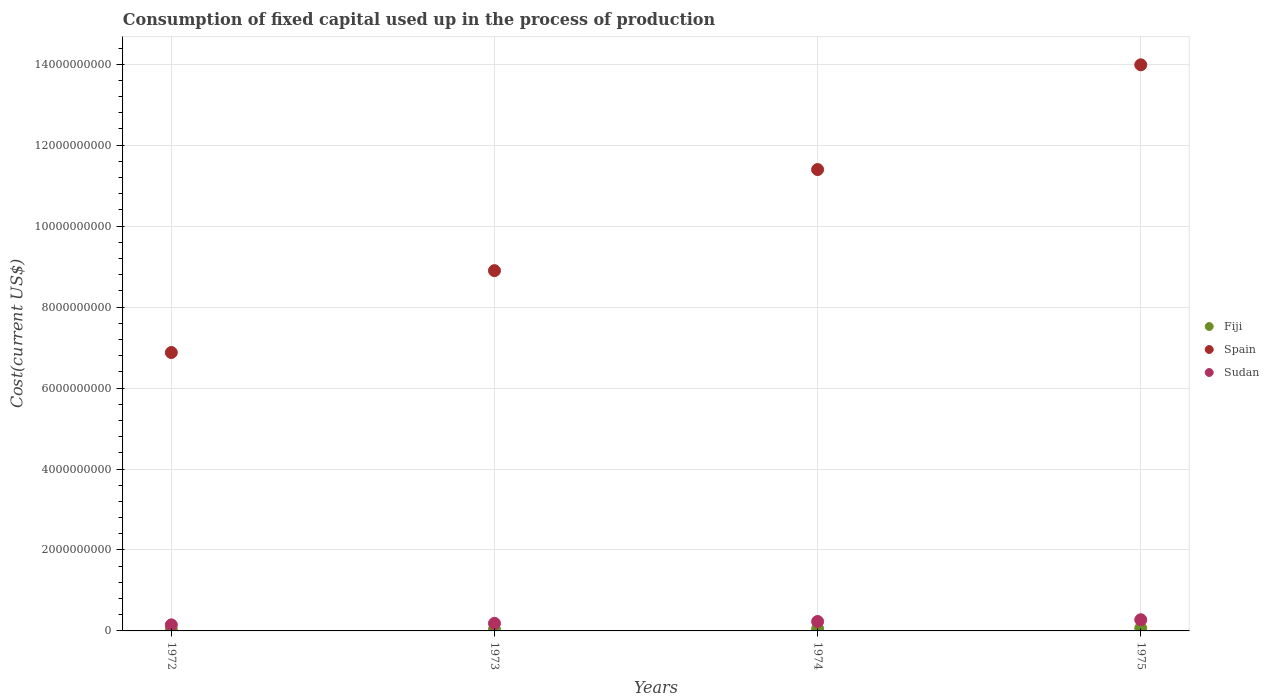What is the amount consumed in the process of production in Spain in 1975?
Provide a short and direct response. 1.40e+1. Across all years, what is the maximum amount consumed in the process of production in Sudan?
Provide a succinct answer. 2.77e+08. Across all years, what is the minimum amount consumed in the process of production in Spain?
Provide a succinct answer. 6.88e+09. In which year was the amount consumed in the process of production in Sudan maximum?
Offer a very short reply. 1975. What is the total amount consumed in the process of production in Sudan in the graph?
Keep it short and to the point. 8.46e+08. What is the difference between the amount consumed in the process of production in Sudan in 1972 and that in 1974?
Make the answer very short. -8.31e+07. What is the difference between the amount consumed in the process of production in Sudan in 1975 and the amount consumed in the process of production in Fiji in 1972?
Your answer should be very brief. 2.48e+08. What is the average amount consumed in the process of production in Spain per year?
Ensure brevity in your answer.  1.03e+1. In the year 1975, what is the difference between the amount consumed in the process of production in Sudan and amount consumed in the process of production in Spain?
Make the answer very short. -1.37e+1. In how many years, is the amount consumed in the process of production in Spain greater than 10400000000 US$?
Provide a short and direct response. 2. What is the ratio of the amount consumed in the process of production in Fiji in 1972 to that in 1975?
Make the answer very short. 0.43. Is the amount consumed in the process of production in Sudan in 1973 less than that in 1974?
Provide a succinct answer. Yes. Is the difference between the amount consumed in the process of production in Sudan in 1974 and 1975 greater than the difference between the amount consumed in the process of production in Spain in 1974 and 1975?
Offer a terse response. Yes. What is the difference between the highest and the second highest amount consumed in the process of production in Fiji?
Your answer should be very brief. 1.29e+07. What is the difference between the highest and the lowest amount consumed in the process of production in Fiji?
Keep it short and to the point. 3.77e+07. Is the sum of the amount consumed in the process of production in Spain in 1973 and 1975 greater than the maximum amount consumed in the process of production in Fiji across all years?
Offer a terse response. Yes. Is it the case that in every year, the sum of the amount consumed in the process of production in Spain and amount consumed in the process of production in Fiji  is greater than the amount consumed in the process of production in Sudan?
Your answer should be very brief. Yes. Does the amount consumed in the process of production in Fiji monotonically increase over the years?
Give a very brief answer. Yes. What is the difference between two consecutive major ticks on the Y-axis?
Keep it short and to the point. 2.00e+09. Does the graph contain any zero values?
Your answer should be compact. No. Where does the legend appear in the graph?
Your response must be concise. Center right. What is the title of the graph?
Your answer should be compact. Consumption of fixed capital used up in the process of production. Does "China" appear as one of the legend labels in the graph?
Offer a very short reply. No. What is the label or title of the X-axis?
Your response must be concise. Years. What is the label or title of the Y-axis?
Make the answer very short. Cost(current US$). What is the Cost(current US$) in Fiji in 1972?
Provide a short and direct response. 2.86e+07. What is the Cost(current US$) in Spain in 1972?
Ensure brevity in your answer.  6.88e+09. What is the Cost(current US$) of Sudan in 1972?
Make the answer very short. 1.50e+08. What is the Cost(current US$) in Fiji in 1973?
Provide a succinct answer. 3.79e+07. What is the Cost(current US$) in Spain in 1973?
Keep it short and to the point. 8.90e+09. What is the Cost(current US$) of Sudan in 1973?
Provide a short and direct response. 1.87e+08. What is the Cost(current US$) in Fiji in 1974?
Your response must be concise. 5.33e+07. What is the Cost(current US$) of Spain in 1974?
Your answer should be very brief. 1.14e+1. What is the Cost(current US$) in Sudan in 1974?
Make the answer very short. 2.33e+08. What is the Cost(current US$) of Fiji in 1975?
Make the answer very short. 6.62e+07. What is the Cost(current US$) in Spain in 1975?
Provide a succinct answer. 1.40e+1. What is the Cost(current US$) of Sudan in 1975?
Provide a succinct answer. 2.77e+08. Across all years, what is the maximum Cost(current US$) of Fiji?
Make the answer very short. 6.62e+07. Across all years, what is the maximum Cost(current US$) of Spain?
Provide a short and direct response. 1.40e+1. Across all years, what is the maximum Cost(current US$) of Sudan?
Give a very brief answer. 2.77e+08. Across all years, what is the minimum Cost(current US$) of Fiji?
Provide a succinct answer. 2.86e+07. Across all years, what is the minimum Cost(current US$) of Spain?
Offer a very short reply. 6.88e+09. Across all years, what is the minimum Cost(current US$) of Sudan?
Your answer should be compact. 1.50e+08. What is the total Cost(current US$) of Fiji in the graph?
Give a very brief answer. 1.86e+08. What is the total Cost(current US$) of Spain in the graph?
Offer a terse response. 4.12e+1. What is the total Cost(current US$) of Sudan in the graph?
Provide a short and direct response. 8.46e+08. What is the difference between the Cost(current US$) in Fiji in 1972 and that in 1973?
Ensure brevity in your answer.  -9.32e+06. What is the difference between the Cost(current US$) of Spain in 1972 and that in 1973?
Offer a terse response. -2.02e+09. What is the difference between the Cost(current US$) in Sudan in 1972 and that in 1973?
Provide a succinct answer. -3.73e+07. What is the difference between the Cost(current US$) in Fiji in 1972 and that in 1974?
Your response must be concise. -2.48e+07. What is the difference between the Cost(current US$) of Spain in 1972 and that in 1974?
Offer a very short reply. -4.52e+09. What is the difference between the Cost(current US$) of Sudan in 1972 and that in 1974?
Keep it short and to the point. -8.31e+07. What is the difference between the Cost(current US$) in Fiji in 1972 and that in 1975?
Provide a succinct answer. -3.77e+07. What is the difference between the Cost(current US$) of Spain in 1972 and that in 1975?
Keep it short and to the point. -7.11e+09. What is the difference between the Cost(current US$) in Sudan in 1972 and that in 1975?
Keep it short and to the point. -1.27e+08. What is the difference between the Cost(current US$) of Fiji in 1973 and that in 1974?
Offer a terse response. -1.55e+07. What is the difference between the Cost(current US$) in Spain in 1973 and that in 1974?
Make the answer very short. -2.50e+09. What is the difference between the Cost(current US$) of Sudan in 1973 and that in 1974?
Your response must be concise. -4.57e+07. What is the difference between the Cost(current US$) in Fiji in 1973 and that in 1975?
Ensure brevity in your answer.  -2.83e+07. What is the difference between the Cost(current US$) in Spain in 1973 and that in 1975?
Provide a short and direct response. -5.08e+09. What is the difference between the Cost(current US$) of Sudan in 1973 and that in 1975?
Ensure brevity in your answer.  -8.95e+07. What is the difference between the Cost(current US$) of Fiji in 1974 and that in 1975?
Make the answer very short. -1.29e+07. What is the difference between the Cost(current US$) in Spain in 1974 and that in 1975?
Provide a short and direct response. -2.59e+09. What is the difference between the Cost(current US$) in Sudan in 1974 and that in 1975?
Your answer should be compact. -4.37e+07. What is the difference between the Cost(current US$) of Fiji in 1972 and the Cost(current US$) of Spain in 1973?
Keep it short and to the point. -8.87e+09. What is the difference between the Cost(current US$) in Fiji in 1972 and the Cost(current US$) in Sudan in 1973?
Ensure brevity in your answer.  -1.59e+08. What is the difference between the Cost(current US$) in Spain in 1972 and the Cost(current US$) in Sudan in 1973?
Your answer should be very brief. 6.69e+09. What is the difference between the Cost(current US$) in Fiji in 1972 and the Cost(current US$) in Spain in 1974?
Keep it short and to the point. -1.14e+1. What is the difference between the Cost(current US$) in Fiji in 1972 and the Cost(current US$) in Sudan in 1974?
Your answer should be compact. -2.04e+08. What is the difference between the Cost(current US$) in Spain in 1972 and the Cost(current US$) in Sudan in 1974?
Provide a succinct answer. 6.64e+09. What is the difference between the Cost(current US$) in Fiji in 1972 and the Cost(current US$) in Spain in 1975?
Give a very brief answer. -1.40e+1. What is the difference between the Cost(current US$) in Fiji in 1972 and the Cost(current US$) in Sudan in 1975?
Provide a succinct answer. -2.48e+08. What is the difference between the Cost(current US$) of Spain in 1972 and the Cost(current US$) of Sudan in 1975?
Ensure brevity in your answer.  6.60e+09. What is the difference between the Cost(current US$) in Fiji in 1973 and the Cost(current US$) in Spain in 1974?
Your answer should be very brief. -1.14e+1. What is the difference between the Cost(current US$) in Fiji in 1973 and the Cost(current US$) in Sudan in 1974?
Keep it short and to the point. -1.95e+08. What is the difference between the Cost(current US$) of Spain in 1973 and the Cost(current US$) of Sudan in 1974?
Your answer should be compact. 8.67e+09. What is the difference between the Cost(current US$) of Fiji in 1973 and the Cost(current US$) of Spain in 1975?
Offer a terse response. -1.39e+1. What is the difference between the Cost(current US$) in Fiji in 1973 and the Cost(current US$) in Sudan in 1975?
Offer a very short reply. -2.39e+08. What is the difference between the Cost(current US$) in Spain in 1973 and the Cost(current US$) in Sudan in 1975?
Provide a short and direct response. 8.62e+09. What is the difference between the Cost(current US$) in Fiji in 1974 and the Cost(current US$) in Spain in 1975?
Offer a terse response. -1.39e+1. What is the difference between the Cost(current US$) of Fiji in 1974 and the Cost(current US$) of Sudan in 1975?
Make the answer very short. -2.23e+08. What is the difference between the Cost(current US$) of Spain in 1974 and the Cost(current US$) of Sudan in 1975?
Ensure brevity in your answer.  1.11e+1. What is the average Cost(current US$) in Fiji per year?
Offer a terse response. 4.65e+07. What is the average Cost(current US$) of Spain per year?
Provide a short and direct response. 1.03e+1. What is the average Cost(current US$) of Sudan per year?
Give a very brief answer. 2.12e+08. In the year 1972, what is the difference between the Cost(current US$) in Fiji and Cost(current US$) in Spain?
Provide a succinct answer. -6.85e+09. In the year 1972, what is the difference between the Cost(current US$) of Fiji and Cost(current US$) of Sudan?
Offer a terse response. -1.21e+08. In the year 1972, what is the difference between the Cost(current US$) of Spain and Cost(current US$) of Sudan?
Your answer should be compact. 6.73e+09. In the year 1973, what is the difference between the Cost(current US$) in Fiji and Cost(current US$) in Spain?
Provide a succinct answer. -8.86e+09. In the year 1973, what is the difference between the Cost(current US$) in Fiji and Cost(current US$) in Sudan?
Ensure brevity in your answer.  -1.49e+08. In the year 1973, what is the difference between the Cost(current US$) of Spain and Cost(current US$) of Sudan?
Ensure brevity in your answer.  8.71e+09. In the year 1974, what is the difference between the Cost(current US$) of Fiji and Cost(current US$) of Spain?
Provide a short and direct response. -1.13e+1. In the year 1974, what is the difference between the Cost(current US$) of Fiji and Cost(current US$) of Sudan?
Offer a terse response. -1.80e+08. In the year 1974, what is the difference between the Cost(current US$) of Spain and Cost(current US$) of Sudan?
Your answer should be very brief. 1.12e+1. In the year 1975, what is the difference between the Cost(current US$) of Fiji and Cost(current US$) of Spain?
Ensure brevity in your answer.  -1.39e+1. In the year 1975, what is the difference between the Cost(current US$) in Fiji and Cost(current US$) in Sudan?
Offer a terse response. -2.10e+08. In the year 1975, what is the difference between the Cost(current US$) of Spain and Cost(current US$) of Sudan?
Provide a succinct answer. 1.37e+1. What is the ratio of the Cost(current US$) of Fiji in 1972 to that in 1973?
Ensure brevity in your answer.  0.75. What is the ratio of the Cost(current US$) in Spain in 1972 to that in 1973?
Keep it short and to the point. 0.77. What is the ratio of the Cost(current US$) in Sudan in 1972 to that in 1973?
Ensure brevity in your answer.  0.8. What is the ratio of the Cost(current US$) in Fiji in 1972 to that in 1974?
Offer a very short reply. 0.54. What is the ratio of the Cost(current US$) in Spain in 1972 to that in 1974?
Your response must be concise. 0.6. What is the ratio of the Cost(current US$) in Sudan in 1972 to that in 1974?
Offer a terse response. 0.64. What is the ratio of the Cost(current US$) of Fiji in 1972 to that in 1975?
Provide a succinct answer. 0.43. What is the ratio of the Cost(current US$) in Spain in 1972 to that in 1975?
Give a very brief answer. 0.49. What is the ratio of the Cost(current US$) of Sudan in 1972 to that in 1975?
Your response must be concise. 0.54. What is the ratio of the Cost(current US$) of Fiji in 1973 to that in 1974?
Ensure brevity in your answer.  0.71. What is the ratio of the Cost(current US$) in Spain in 1973 to that in 1974?
Give a very brief answer. 0.78. What is the ratio of the Cost(current US$) of Sudan in 1973 to that in 1974?
Give a very brief answer. 0.8. What is the ratio of the Cost(current US$) in Fiji in 1973 to that in 1975?
Your answer should be very brief. 0.57. What is the ratio of the Cost(current US$) in Spain in 1973 to that in 1975?
Your answer should be compact. 0.64. What is the ratio of the Cost(current US$) of Sudan in 1973 to that in 1975?
Your response must be concise. 0.68. What is the ratio of the Cost(current US$) in Fiji in 1974 to that in 1975?
Make the answer very short. 0.81. What is the ratio of the Cost(current US$) in Spain in 1974 to that in 1975?
Keep it short and to the point. 0.81. What is the ratio of the Cost(current US$) in Sudan in 1974 to that in 1975?
Provide a succinct answer. 0.84. What is the difference between the highest and the second highest Cost(current US$) of Fiji?
Your response must be concise. 1.29e+07. What is the difference between the highest and the second highest Cost(current US$) of Spain?
Make the answer very short. 2.59e+09. What is the difference between the highest and the second highest Cost(current US$) of Sudan?
Offer a terse response. 4.37e+07. What is the difference between the highest and the lowest Cost(current US$) in Fiji?
Provide a short and direct response. 3.77e+07. What is the difference between the highest and the lowest Cost(current US$) of Spain?
Your answer should be very brief. 7.11e+09. What is the difference between the highest and the lowest Cost(current US$) of Sudan?
Your answer should be very brief. 1.27e+08. 